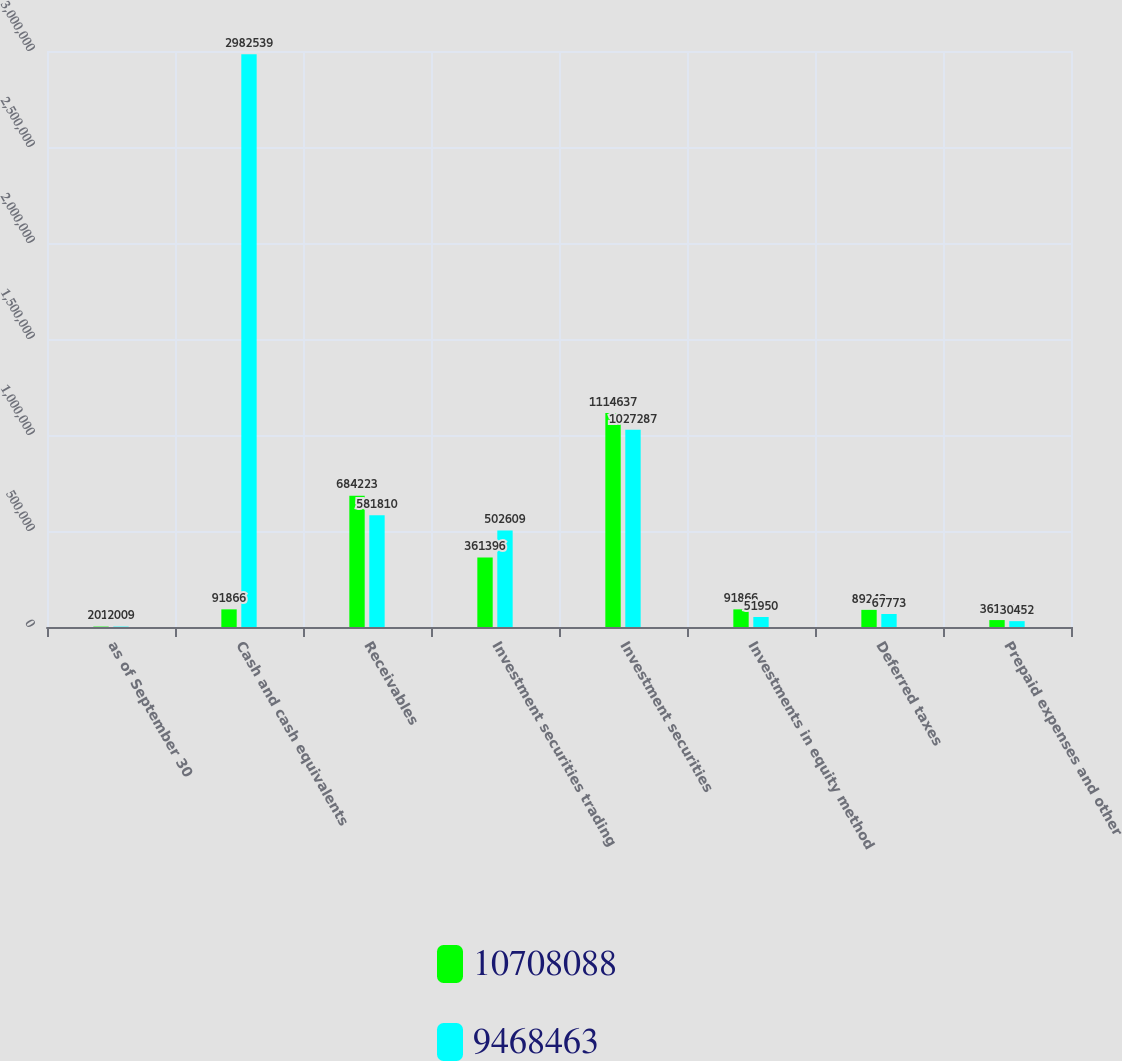<chart> <loc_0><loc_0><loc_500><loc_500><stacked_bar_chart><ecel><fcel>as of September 30<fcel>Cash and cash equivalents<fcel>Receivables<fcel>Investment securities trading<fcel>Investment securities<fcel>Investments in equity method<fcel>Deferred taxes<fcel>Prepaid expenses and other<nl><fcel>1.07081e+07<fcel>2010<fcel>91866<fcel>684223<fcel>361396<fcel>1.11464e+06<fcel>91866<fcel>89242<fcel>36117<nl><fcel>9.46846e+06<fcel>2009<fcel>2.98254e+06<fcel>581810<fcel>502609<fcel>1.02729e+06<fcel>51950<fcel>67773<fcel>30452<nl></chart> 